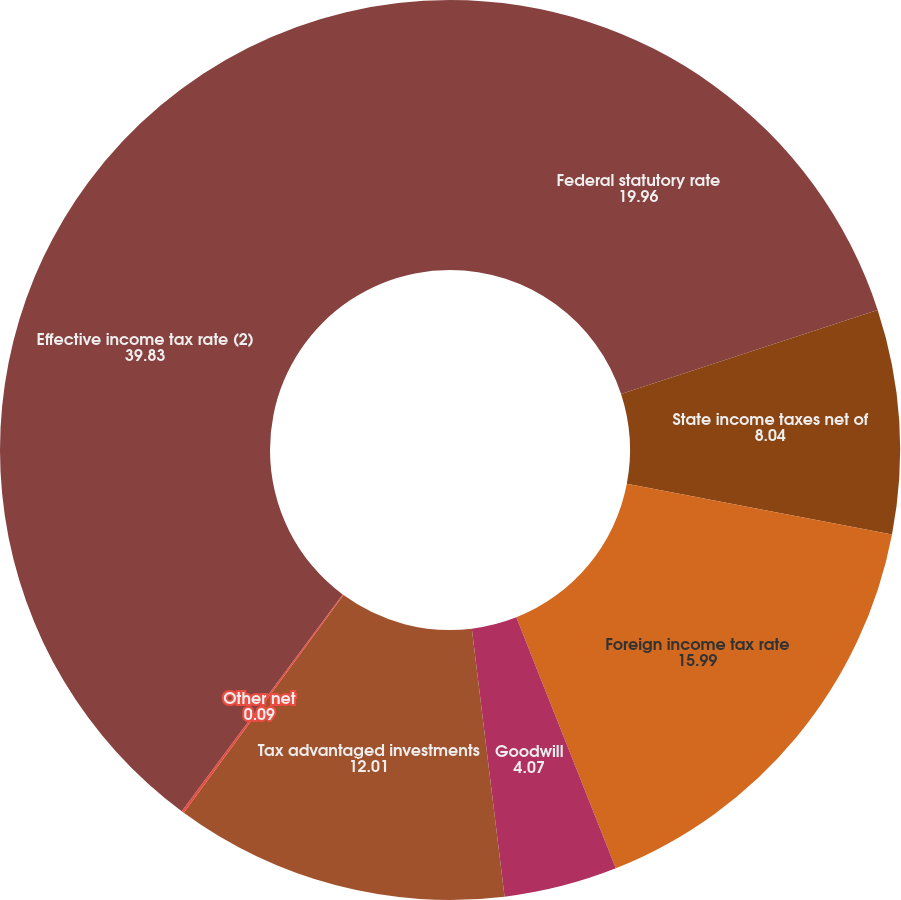Convert chart to OTSL. <chart><loc_0><loc_0><loc_500><loc_500><pie_chart><fcel>Federal statutory rate<fcel>State income taxes net of<fcel>Foreign income tax rate<fcel>Goodwill<fcel>Tax advantaged investments<fcel>Other net<fcel>Effective income tax rate (2)<nl><fcel>19.96%<fcel>8.04%<fcel>15.99%<fcel>4.07%<fcel>12.01%<fcel>0.09%<fcel>39.83%<nl></chart> 